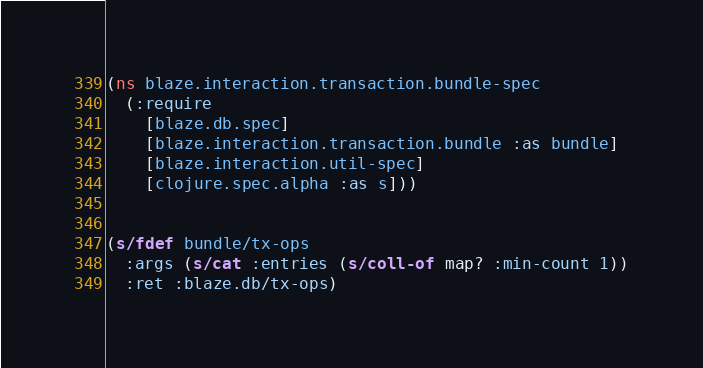Convert code to text. <code><loc_0><loc_0><loc_500><loc_500><_Clojure_>(ns blaze.interaction.transaction.bundle-spec
  (:require
    [blaze.db.spec]
    [blaze.interaction.transaction.bundle :as bundle]
    [blaze.interaction.util-spec]
    [clojure.spec.alpha :as s]))


(s/fdef bundle/tx-ops
  :args (s/cat :entries (s/coll-of map? :min-count 1))
  :ret :blaze.db/tx-ops)
</code> 